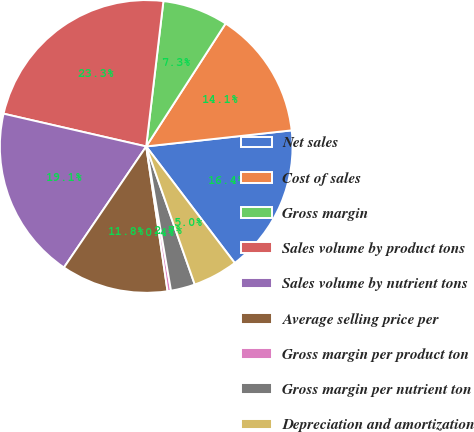<chart> <loc_0><loc_0><loc_500><loc_500><pie_chart><fcel>Net sales<fcel>Cost of sales<fcel>Gross margin<fcel>Sales volume by product tons<fcel>Sales volume by nutrient tons<fcel>Average selling price per<fcel>Gross margin per product ton<fcel>Gross margin per nutrient ton<fcel>Depreciation and amortization<nl><fcel>16.41%<fcel>14.12%<fcel>7.25%<fcel>23.28%<fcel>19.09%<fcel>11.83%<fcel>0.38%<fcel>2.67%<fcel>4.96%<nl></chart> 